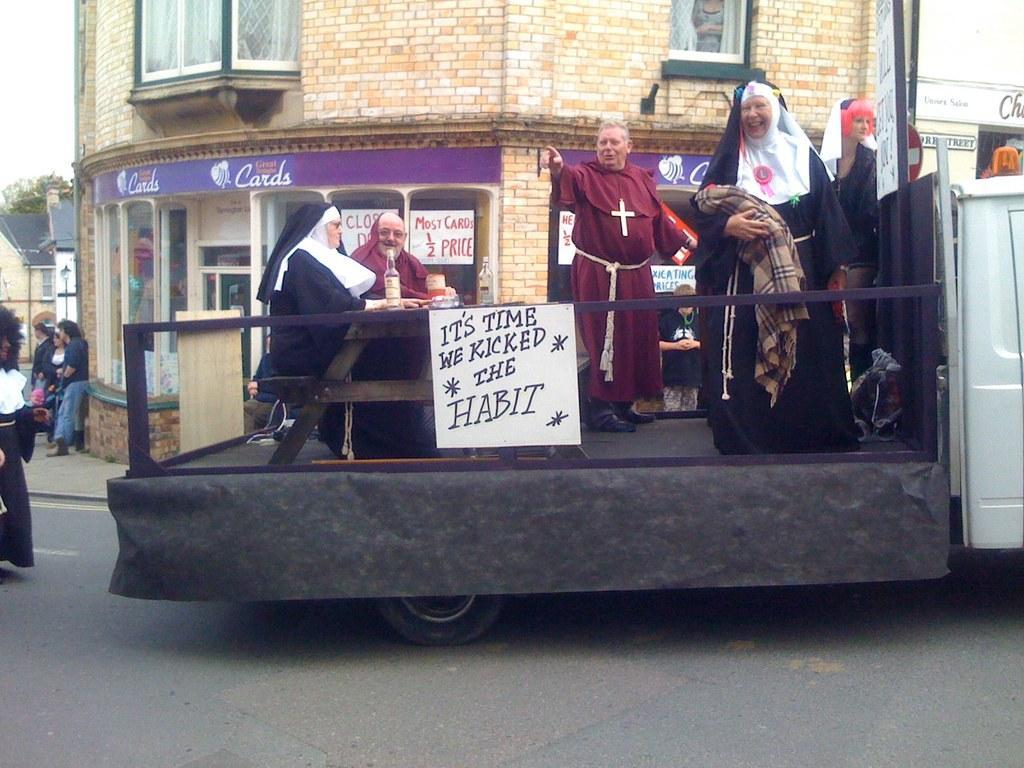Could you give a brief overview of what you see in this image? In the picture we can see a truck on it we can see some people are dressed in the church people costumes and behind it we can see a part of the building with shops and near to it we can see some people are standing and beside them we can see some houses far away from them and poles with lamps and behind it we can see some trees and the sky. 